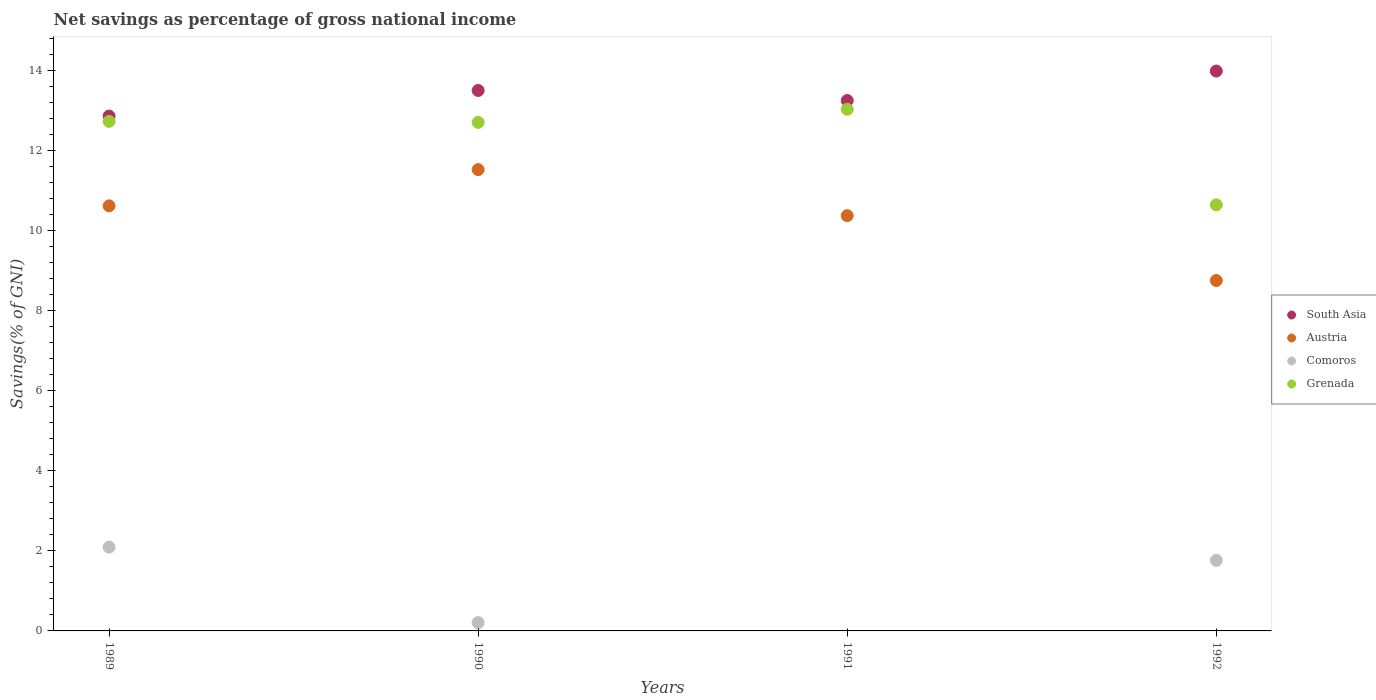How many different coloured dotlines are there?
Offer a terse response. 4. What is the total savings in Grenada in 1991?
Your response must be concise. 13.02. Across all years, what is the maximum total savings in Comoros?
Give a very brief answer. 2.09. Across all years, what is the minimum total savings in Austria?
Provide a short and direct response. 8.75. In which year was the total savings in Grenada maximum?
Keep it short and to the point. 1991. What is the total total savings in Austria in the graph?
Give a very brief answer. 41.24. What is the difference between the total savings in Comoros in 1989 and that in 1990?
Make the answer very short. 1.88. What is the difference between the total savings in Grenada in 1991 and the total savings in Comoros in 1989?
Ensure brevity in your answer.  10.93. What is the average total savings in Austria per year?
Offer a very short reply. 10.31. In the year 1992, what is the difference between the total savings in Comoros and total savings in Austria?
Provide a short and direct response. -6.99. In how many years, is the total savings in Grenada greater than 12.8 %?
Offer a very short reply. 1. What is the ratio of the total savings in Austria in 1991 to that in 1992?
Ensure brevity in your answer.  1.19. Is the difference between the total savings in Comoros in 1990 and 1992 greater than the difference between the total savings in Austria in 1990 and 1992?
Your response must be concise. No. What is the difference between the highest and the second highest total savings in Grenada?
Ensure brevity in your answer.  0.3. What is the difference between the highest and the lowest total savings in Comoros?
Offer a terse response. 2.09. In how many years, is the total savings in Austria greater than the average total savings in Austria taken over all years?
Keep it short and to the point. 3. Is it the case that in every year, the sum of the total savings in Grenada and total savings in Austria  is greater than the total savings in South Asia?
Offer a terse response. Yes. How many dotlines are there?
Provide a short and direct response. 4. Are the values on the major ticks of Y-axis written in scientific E-notation?
Keep it short and to the point. No. Does the graph contain any zero values?
Offer a terse response. Yes. Does the graph contain grids?
Provide a short and direct response. No. How are the legend labels stacked?
Provide a short and direct response. Vertical. What is the title of the graph?
Give a very brief answer. Net savings as percentage of gross national income. Does "Jordan" appear as one of the legend labels in the graph?
Your answer should be very brief. No. What is the label or title of the X-axis?
Make the answer very short. Years. What is the label or title of the Y-axis?
Give a very brief answer. Savings(% of GNI). What is the Savings(% of GNI) of South Asia in 1989?
Provide a succinct answer. 12.85. What is the Savings(% of GNI) of Austria in 1989?
Offer a terse response. 10.61. What is the Savings(% of GNI) in Comoros in 1989?
Make the answer very short. 2.09. What is the Savings(% of GNI) in Grenada in 1989?
Your answer should be very brief. 12.72. What is the Savings(% of GNI) in South Asia in 1990?
Make the answer very short. 13.49. What is the Savings(% of GNI) of Austria in 1990?
Make the answer very short. 11.51. What is the Savings(% of GNI) in Comoros in 1990?
Offer a terse response. 0.21. What is the Savings(% of GNI) of Grenada in 1990?
Provide a short and direct response. 12.69. What is the Savings(% of GNI) in South Asia in 1991?
Offer a very short reply. 13.24. What is the Savings(% of GNI) of Austria in 1991?
Your answer should be very brief. 10.37. What is the Savings(% of GNI) in Comoros in 1991?
Your answer should be very brief. 0. What is the Savings(% of GNI) of Grenada in 1991?
Provide a short and direct response. 13.02. What is the Savings(% of GNI) in South Asia in 1992?
Your answer should be compact. 13.98. What is the Savings(% of GNI) of Austria in 1992?
Make the answer very short. 8.75. What is the Savings(% of GNI) in Comoros in 1992?
Your answer should be very brief. 1.76. What is the Savings(% of GNI) in Grenada in 1992?
Ensure brevity in your answer.  10.64. Across all years, what is the maximum Savings(% of GNI) of South Asia?
Offer a very short reply. 13.98. Across all years, what is the maximum Savings(% of GNI) of Austria?
Ensure brevity in your answer.  11.51. Across all years, what is the maximum Savings(% of GNI) in Comoros?
Keep it short and to the point. 2.09. Across all years, what is the maximum Savings(% of GNI) in Grenada?
Your answer should be very brief. 13.02. Across all years, what is the minimum Savings(% of GNI) of South Asia?
Ensure brevity in your answer.  12.85. Across all years, what is the minimum Savings(% of GNI) in Austria?
Keep it short and to the point. 8.75. Across all years, what is the minimum Savings(% of GNI) in Comoros?
Provide a short and direct response. 0. Across all years, what is the minimum Savings(% of GNI) of Grenada?
Ensure brevity in your answer.  10.64. What is the total Savings(% of GNI) in South Asia in the graph?
Offer a terse response. 53.56. What is the total Savings(% of GNI) in Austria in the graph?
Offer a terse response. 41.24. What is the total Savings(% of GNI) of Comoros in the graph?
Your response must be concise. 4.06. What is the total Savings(% of GNI) of Grenada in the graph?
Make the answer very short. 49.07. What is the difference between the Savings(% of GNI) of South Asia in 1989 and that in 1990?
Offer a terse response. -0.64. What is the difference between the Savings(% of GNI) in Austria in 1989 and that in 1990?
Make the answer very short. -0.9. What is the difference between the Savings(% of GNI) of Comoros in 1989 and that in 1990?
Your answer should be compact. 1.88. What is the difference between the Savings(% of GNI) of Grenada in 1989 and that in 1990?
Ensure brevity in your answer.  0.03. What is the difference between the Savings(% of GNI) of South Asia in 1989 and that in 1991?
Your answer should be compact. -0.39. What is the difference between the Savings(% of GNI) of Austria in 1989 and that in 1991?
Your answer should be very brief. 0.24. What is the difference between the Savings(% of GNI) in Grenada in 1989 and that in 1991?
Provide a succinct answer. -0.3. What is the difference between the Savings(% of GNI) in South Asia in 1989 and that in 1992?
Provide a succinct answer. -1.12. What is the difference between the Savings(% of GNI) of Austria in 1989 and that in 1992?
Provide a succinct answer. 1.86. What is the difference between the Savings(% of GNI) in Comoros in 1989 and that in 1992?
Your answer should be very brief. 0.33. What is the difference between the Savings(% of GNI) of Grenada in 1989 and that in 1992?
Offer a very short reply. 2.08. What is the difference between the Savings(% of GNI) in South Asia in 1990 and that in 1991?
Offer a very short reply. 0.25. What is the difference between the Savings(% of GNI) in Austria in 1990 and that in 1991?
Provide a succinct answer. 1.15. What is the difference between the Savings(% of GNI) in Grenada in 1990 and that in 1991?
Keep it short and to the point. -0.33. What is the difference between the Savings(% of GNI) in South Asia in 1990 and that in 1992?
Provide a short and direct response. -0.48. What is the difference between the Savings(% of GNI) of Austria in 1990 and that in 1992?
Offer a terse response. 2.77. What is the difference between the Savings(% of GNI) of Comoros in 1990 and that in 1992?
Keep it short and to the point. -1.55. What is the difference between the Savings(% of GNI) of Grenada in 1990 and that in 1992?
Your response must be concise. 2.06. What is the difference between the Savings(% of GNI) of South Asia in 1991 and that in 1992?
Keep it short and to the point. -0.74. What is the difference between the Savings(% of GNI) in Austria in 1991 and that in 1992?
Give a very brief answer. 1.62. What is the difference between the Savings(% of GNI) in Grenada in 1991 and that in 1992?
Your answer should be very brief. 2.38. What is the difference between the Savings(% of GNI) in South Asia in 1989 and the Savings(% of GNI) in Austria in 1990?
Offer a terse response. 1.34. What is the difference between the Savings(% of GNI) in South Asia in 1989 and the Savings(% of GNI) in Comoros in 1990?
Make the answer very short. 12.64. What is the difference between the Savings(% of GNI) in South Asia in 1989 and the Savings(% of GNI) in Grenada in 1990?
Your answer should be compact. 0.16. What is the difference between the Savings(% of GNI) in Austria in 1989 and the Savings(% of GNI) in Comoros in 1990?
Give a very brief answer. 10.4. What is the difference between the Savings(% of GNI) of Austria in 1989 and the Savings(% of GNI) of Grenada in 1990?
Make the answer very short. -2.08. What is the difference between the Savings(% of GNI) of Comoros in 1989 and the Savings(% of GNI) of Grenada in 1990?
Offer a terse response. -10.6. What is the difference between the Savings(% of GNI) of South Asia in 1989 and the Savings(% of GNI) of Austria in 1991?
Keep it short and to the point. 2.49. What is the difference between the Savings(% of GNI) in South Asia in 1989 and the Savings(% of GNI) in Grenada in 1991?
Ensure brevity in your answer.  -0.17. What is the difference between the Savings(% of GNI) of Austria in 1989 and the Savings(% of GNI) of Grenada in 1991?
Keep it short and to the point. -2.41. What is the difference between the Savings(% of GNI) of Comoros in 1989 and the Savings(% of GNI) of Grenada in 1991?
Provide a short and direct response. -10.93. What is the difference between the Savings(% of GNI) in South Asia in 1989 and the Savings(% of GNI) in Austria in 1992?
Your response must be concise. 4.11. What is the difference between the Savings(% of GNI) of South Asia in 1989 and the Savings(% of GNI) of Comoros in 1992?
Keep it short and to the point. 11.09. What is the difference between the Savings(% of GNI) in South Asia in 1989 and the Savings(% of GNI) in Grenada in 1992?
Offer a very short reply. 2.22. What is the difference between the Savings(% of GNI) of Austria in 1989 and the Savings(% of GNI) of Comoros in 1992?
Your response must be concise. 8.85. What is the difference between the Savings(% of GNI) in Austria in 1989 and the Savings(% of GNI) in Grenada in 1992?
Provide a succinct answer. -0.03. What is the difference between the Savings(% of GNI) of Comoros in 1989 and the Savings(% of GNI) of Grenada in 1992?
Provide a succinct answer. -8.55. What is the difference between the Savings(% of GNI) of South Asia in 1990 and the Savings(% of GNI) of Austria in 1991?
Your answer should be compact. 3.12. What is the difference between the Savings(% of GNI) in South Asia in 1990 and the Savings(% of GNI) in Grenada in 1991?
Your answer should be very brief. 0.47. What is the difference between the Savings(% of GNI) in Austria in 1990 and the Savings(% of GNI) in Grenada in 1991?
Give a very brief answer. -1.51. What is the difference between the Savings(% of GNI) of Comoros in 1990 and the Savings(% of GNI) of Grenada in 1991?
Make the answer very short. -12.81. What is the difference between the Savings(% of GNI) of South Asia in 1990 and the Savings(% of GNI) of Austria in 1992?
Offer a terse response. 4.74. What is the difference between the Savings(% of GNI) of South Asia in 1990 and the Savings(% of GNI) of Comoros in 1992?
Your answer should be compact. 11.73. What is the difference between the Savings(% of GNI) of South Asia in 1990 and the Savings(% of GNI) of Grenada in 1992?
Your answer should be very brief. 2.85. What is the difference between the Savings(% of GNI) of Austria in 1990 and the Savings(% of GNI) of Comoros in 1992?
Ensure brevity in your answer.  9.75. What is the difference between the Savings(% of GNI) in Austria in 1990 and the Savings(% of GNI) in Grenada in 1992?
Keep it short and to the point. 0.88. What is the difference between the Savings(% of GNI) of Comoros in 1990 and the Savings(% of GNI) of Grenada in 1992?
Offer a very short reply. -10.43. What is the difference between the Savings(% of GNI) in South Asia in 1991 and the Savings(% of GNI) in Austria in 1992?
Give a very brief answer. 4.49. What is the difference between the Savings(% of GNI) in South Asia in 1991 and the Savings(% of GNI) in Comoros in 1992?
Provide a succinct answer. 11.48. What is the difference between the Savings(% of GNI) in South Asia in 1991 and the Savings(% of GNI) in Grenada in 1992?
Provide a succinct answer. 2.6. What is the difference between the Savings(% of GNI) in Austria in 1991 and the Savings(% of GNI) in Comoros in 1992?
Your answer should be compact. 8.6. What is the difference between the Savings(% of GNI) of Austria in 1991 and the Savings(% of GNI) of Grenada in 1992?
Provide a short and direct response. -0.27. What is the average Savings(% of GNI) in South Asia per year?
Offer a terse response. 13.39. What is the average Savings(% of GNI) in Austria per year?
Keep it short and to the point. 10.31. What is the average Savings(% of GNI) of Comoros per year?
Provide a succinct answer. 1.01. What is the average Savings(% of GNI) of Grenada per year?
Offer a very short reply. 12.27. In the year 1989, what is the difference between the Savings(% of GNI) of South Asia and Savings(% of GNI) of Austria?
Your response must be concise. 2.24. In the year 1989, what is the difference between the Savings(% of GNI) in South Asia and Savings(% of GNI) in Comoros?
Provide a short and direct response. 10.76. In the year 1989, what is the difference between the Savings(% of GNI) in South Asia and Savings(% of GNI) in Grenada?
Provide a short and direct response. 0.13. In the year 1989, what is the difference between the Savings(% of GNI) in Austria and Savings(% of GNI) in Comoros?
Provide a succinct answer. 8.52. In the year 1989, what is the difference between the Savings(% of GNI) of Austria and Savings(% of GNI) of Grenada?
Provide a succinct answer. -2.11. In the year 1989, what is the difference between the Savings(% of GNI) in Comoros and Savings(% of GNI) in Grenada?
Offer a terse response. -10.63. In the year 1990, what is the difference between the Savings(% of GNI) in South Asia and Savings(% of GNI) in Austria?
Offer a very short reply. 1.98. In the year 1990, what is the difference between the Savings(% of GNI) in South Asia and Savings(% of GNI) in Comoros?
Provide a short and direct response. 13.28. In the year 1990, what is the difference between the Savings(% of GNI) in South Asia and Savings(% of GNI) in Grenada?
Provide a succinct answer. 0.8. In the year 1990, what is the difference between the Savings(% of GNI) of Austria and Savings(% of GNI) of Comoros?
Ensure brevity in your answer.  11.31. In the year 1990, what is the difference between the Savings(% of GNI) of Austria and Savings(% of GNI) of Grenada?
Your answer should be very brief. -1.18. In the year 1990, what is the difference between the Savings(% of GNI) of Comoros and Savings(% of GNI) of Grenada?
Give a very brief answer. -12.49. In the year 1991, what is the difference between the Savings(% of GNI) in South Asia and Savings(% of GNI) in Austria?
Offer a terse response. 2.87. In the year 1991, what is the difference between the Savings(% of GNI) of South Asia and Savings(% of GNI) of Grenada?
Your response must be concise. 0.22. In the year 1991, what is the difference between the Savings(% of GNI) of Austria and Savings(% of GNI) of Grenada?
Offer a terse response. -2.66. In the year 1992, what is the difference between the Savings(% of GNI) of South Asia and Savings(% of GNI) of Austria?
Your answer should be very brief. 5.23. In the year 1992, what is the difference between the Savings(% of GNI) of South Asia and Savings(% of GNI) of Comoros?
Provide a succinct answer. 12.21. In the year 1992, what is the difference between the Savings(% of GNI) of South Asia and Savings(% of GNI) of Grenada?
Make the answer very short. 3.34. In the year 1992, what is the difference between the Savings(% of GNI) of Austria and Savings(% of GNI) of Comoros?
Provide a succinct answer. 6.99. In the year 1992, what is the difference between the Savings(% of GNI) of Austria and Savings(% of GNI) of Grenada?
Provide a short and direct response. -1.89. In the year 1992, what is the difference between the Savings(% of GNI) of Comoros and Savings(% of GNI) of Grenada?
Ensure brevity in your answer.  -8.88. What is the ratio of the Savings(% of GNI) of South Asia in 1989 to that in 1990?
Make the answer very short. 0.95. What is the ratio of the Savings(% of GNI) of Austria in 1989 to that in 1990?
Your answer should be compact. 0.92. What is the ratio of the Savings(% of GNI) of Comoros in 1989 to that in 1990?
Keep it short and to the point. 10.09. What is the ratio of the Savings(% of GNI) of Grenada in 1989 to that in 1990?
Offer a terse response. 1. What is the ratio of the Savings(% of GNI) in South Asia in 1989 to that in 1991?
Keep it short and to the point. 0.97. What is the ratio of the Savings(% of GNI) of Austria in 1989 to that in 1991?
Ensure brevity in your answer.  1.02. What is the ratio of the Savings(% of GNI) in Grenada in 1989 to that in 1991?
Keep it short and to the point. 0.98. What is the ratio of the Savings(% of GNI) in South Asia in 1989 to that in 1992?
Your answer should be very brief. 0.92. What is the ratio of the Savings(% of GNI) of Austria in 1989 to that in 1992?
Offer a terse response. 1.21. What is the ratio of the Savings(% of GNI) in Comoros in 1989 to that in 1992?
Provide a succinct answer. 1.19. What is the ratio of the Savings(% of GNI) of Grenada in 1989 to that in 1992?
Your answer should be compact. 1.2. What is the ratio of the Savings(% of GNI) in South Asia in 1990 to that in 1991?
Your response must be concise. 1.02. What is the ratio of the Savings(% of GNI) in Austria in 1990 to that in 1991?
Provide a succinct answer. 1.11. What is the ratio of the Savings(% of GNI) of Grenada in 1990 to that in 1991?
Your answer should be compact. 0.97. What is the ratio of the Savings(% of GNI) of South Asia in 1990 to that in 1992?
Give a very brief answer. 0.97. What is the ratio of the Savings(% of GNI) of Austria in 1990 to that in 1992?
Offer a very short reply. 1.32. What is the ratio of the Savings(% of GNI) of Comoros in 1990 to that in 1992?
Give a very brief answer. 0.12. What is the ratio of the Savings(% of GNI) in Grenada in 1990 to that in 1992?
Provide a succinct answer. 1.19. What is the ratio of the Savings(% of GNI) of South Asia in 1991 to that in 1992?
Offer a very short reply. 0.95. What is the ratio of the Savings(% of GNI) in Austria in 1991 to that in 1992?
Provide a succinct answer. 1.19. What is the ratio of the Savings(% of GNI) in Grenada in 1991 to that in 1992?
Offer a very short reply. 1.22. What is the difference between the highest and the second highest Savings(% of GNI) of South Asia?
Your answer should be very brief. 0.48. What is the difference between the highest and the second highest Savings(% of GNI) in Austria?
Ensure brevity in your answer.  0.9. What is the difference between the highest and the second highest Savings(% of GNI) in Comoros?
Provide a succinct answer. 0.33. What is the difference between the highest and the second highest Savings(% of GNI) in Grenada?
Give a very brief answer. 0.3. What is the difference between the highest and the lowest Savings(% of GNI) of South Asia?
Your answer should be compact. 1.12. What is the difference between the highest and the lowest Savings(% of GNI) in Austria?
Make the answer very short. 2.77. What is the difference between the highest and the lowest Savings(% of GNI) in Comoros?
Your response must be concise. 2.09. What is the difference between the highest and the lowest Savings(% of GNI) of Grenada?
Your response must be concise. 2.38. 